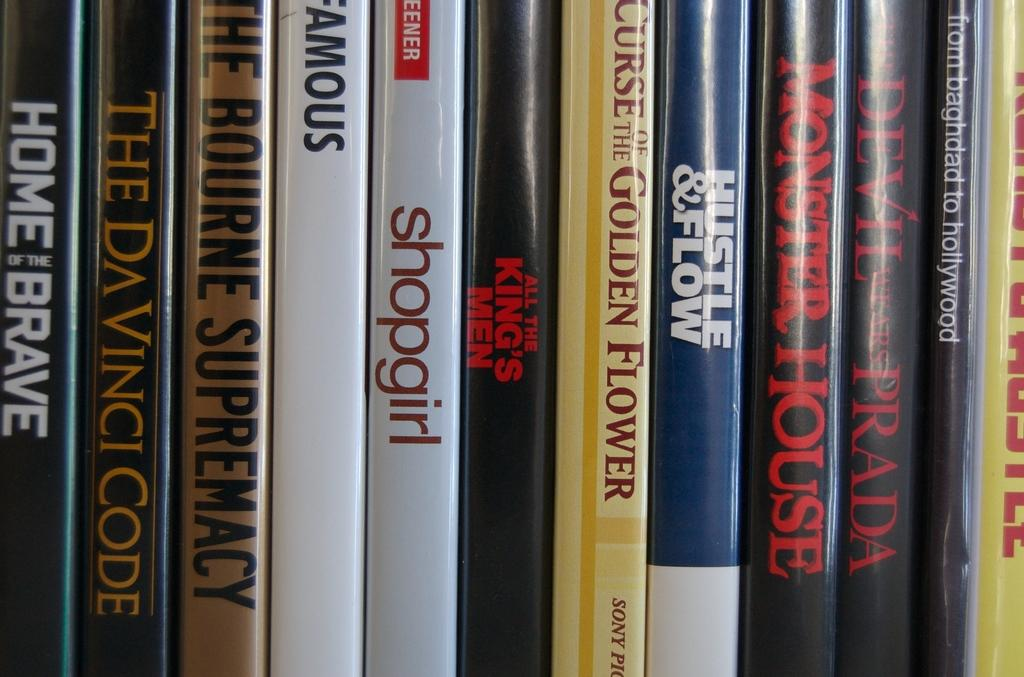<image>
Give a short and clear explanation of the subsequent image. Various movies lined up on on a shelf that includes The DaVinci Code and Shopgirl 